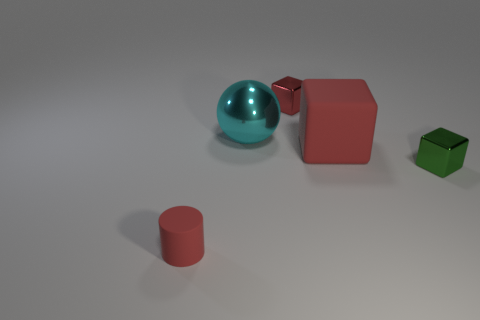Subtract all blue balls. How many red blocks are left? 2 Subtract all red rubber blocks. How many blocks are left? 2 Add 4 large blocks. How many objects exist? 9 Subtract all green cubes. How many cubes are left? 2 Subtract 1 blocks. How many blocks are left? 2 Subtract all cylinders. How many objects are left? 4 Subtract all cyan cylinders. Subtract all gray blocks. How many cylinders are left? 1 Subtract all big cyan metallic things. Subtract all metallic balls. How many objects are left? 3 Add 5 small cubes. How many small cubes are left? 7 Add 1 blocks. How many blocks exist? 4 